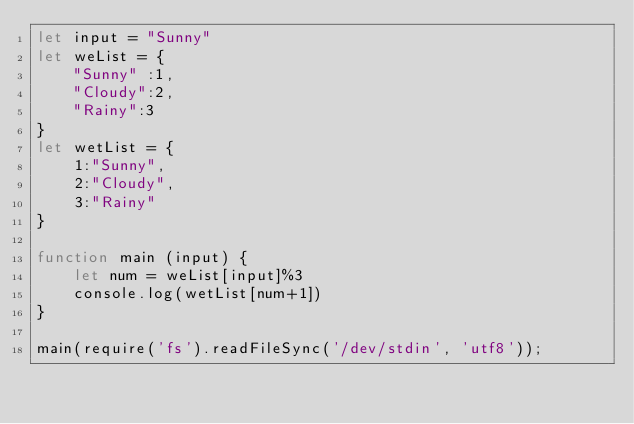Convert code to text. <code><loc_0><loc_0><loc_500><loc_500><_JavaScript_>let input = "Sunny"
let weList = {
    "Sunny" :1,
    "Cloudy":2,
    "Rainy":3
}
let wetList = {
    1:"Sunny",
    2:"Cloudy",
    3:"Rainy"
}

function main (input) {
    let num = weList[input]%3
    console.log(wetList[num+1])
}

main(require('fs').readFileSync('/dev/stdin', 'utf8'));</code> 